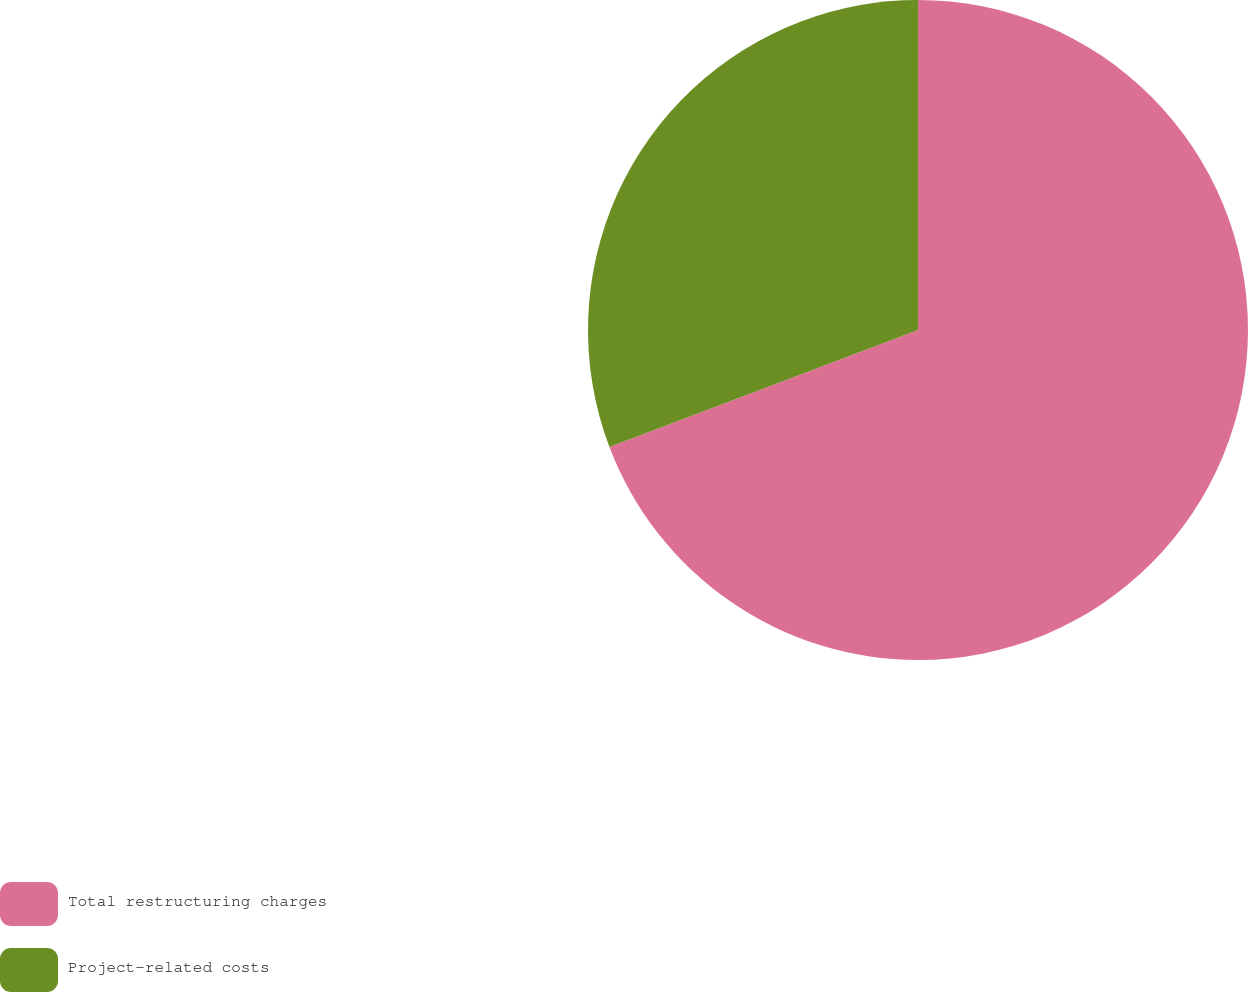Convert chart to OTSL. <chart><loc_0><loc_0><loc_500><loc_500><pie_chart><fcel>Total restructuring charges<fcel>Project-related costs<nl><fcel>69.23%<fcel>30.77%<nl></chart> 